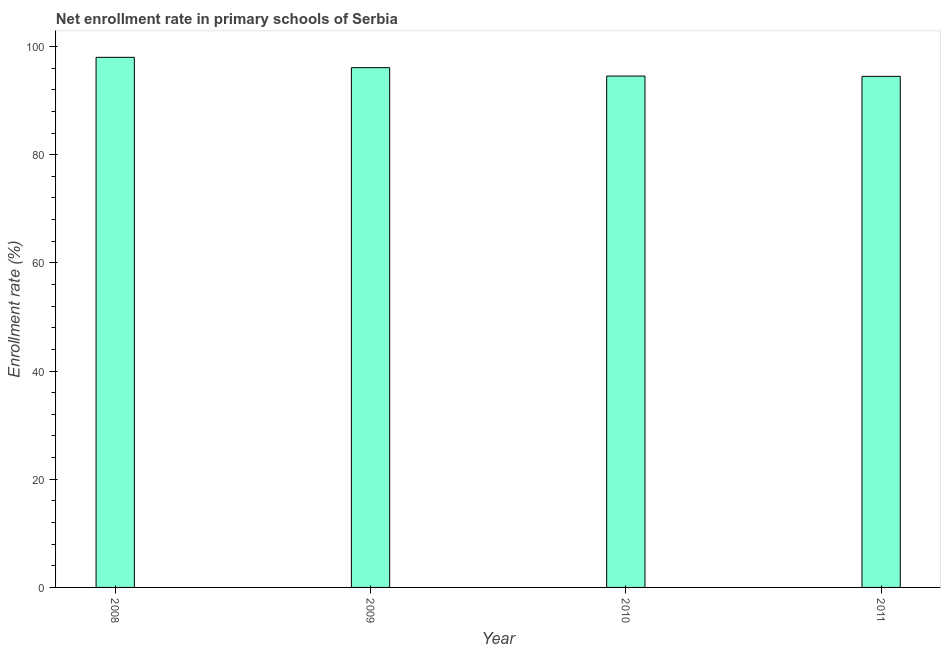What is the title of the graph?
Make the answer very short. Net enrollment rate in primary schools of Serbia. What is the label or title of the X-axis?
Give a very brief answer. Year. What is the label or title of the Y-axis?
Provide a succinct answer. Enrollment rate (%). What is the net enrollment rate in primary schools in 2010?
Ensure brevity in your answer.  94.54. Across all years, what is the maximum net enrollment rate in primary schools?
Provide a succinct answer. 98. Across all years, what is the minimum net enrollment rate in primary schools?
Make the answer very short. 94.48. What is the sum of the net enrollment rate in primary schools?
Keep it short and to the point. 383.1. What is the difference between the net enrollment rate in primary schools in 2008 and 2010?
Provide a short and direct response. 3.46. What is the average net enrollment rate in primary schools per year?
Ensure brevity in your answer.  95.78. What is the median net enrollment rate in primary schools?
Offer a very short reply. 95.31. Do a majority of the years between 2008 and 2009 (inclusive) have net enrollment rate in primary schools greater than 72 %?
Make the answer very short. Yes. What is the ratio of the net enrollment rate in primary schools in 2008 to that in 2011?
Make the answer very short. 1.04. Is the difference between the net enrollment rate in primary schools in 2008 and 2011 greater than the difference between any two years?
Your response must be concise. Yes. What is the difference between the highest and the second highest net enrollment rate in primary schools?
Provide a short and direct response. 1.91. What is the difference between the highest and the lowest net enrollment rate in primary schools?
Ensure brevity in your answer.  3.52. Are the values on the major ticks of Y-axis written in scientific E-notation?
Your answer should be very brief. No. What is the Enrollment rate (%) of 2008?
Make the answer very short. 98. What is the Enrollment rate (%) of 2009?
Ensure brevity in your answer.  96.09. What is the Enrollment rate (%) in 2010?
Keep it short and to the point. 94.54. What is the Enrollment rate (%) in 2011?
Your answer should be compact. 94.48. What is the difference between the Enrollment rate (%) in 2008 and 2009?
Keep it short and to the point. 1.91. What is the difference between the Enrollment rate (%) in 2008 and 2010?
Offer a terse response. 3.46. What is the difference between the Enrollment rate (%) in 2008 and 2011?
Offer a terse response. 3.52. What is the difference between the Enrollment rate (%) in 2009 and 2010?
Give a very brief answer. 1.55. What is the difference between the Enrollment rate (%) in 2009 and 2011?
Provide a short and direct response. 1.61. What is the difference between the Enrollment rate (%) in 2010 and 2011?
Ensure brevity in your answer.  0.05. What is the ratio of the Enrollment rate (%) in 2009 to that in 2010?
Give a very brief answer. 1.02. What is the ratio of the Enrollment rate (%) in 2009 to that in 2011?
Make the answer very short. 1.02. 